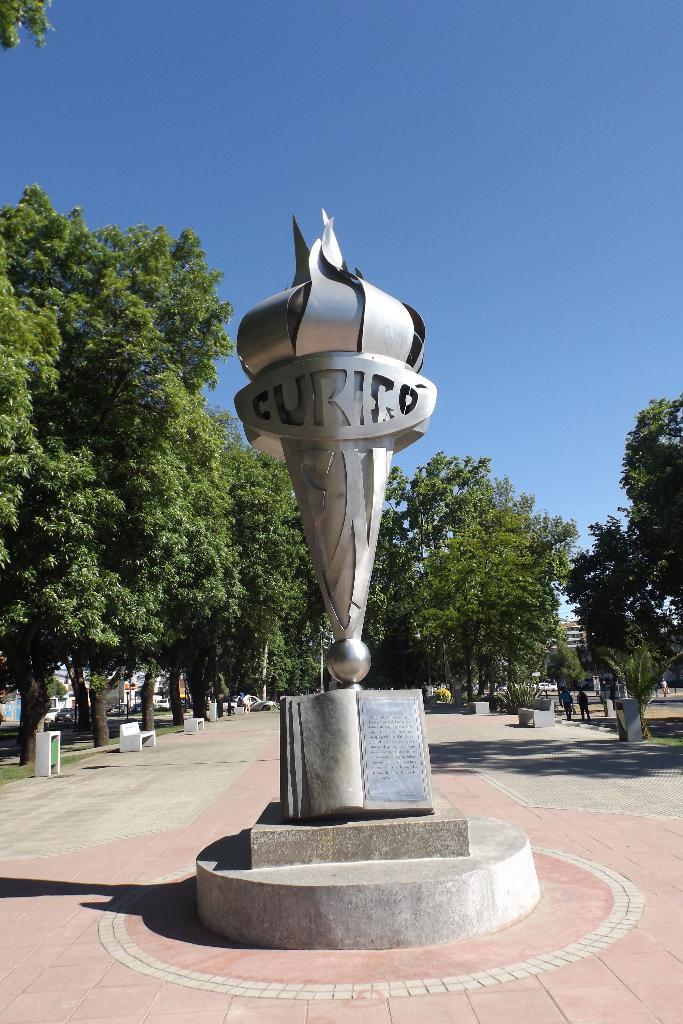What word is in the statue?
Your response must be concise. Curico. What is the symbol?
Ensure brevity in your answer.  Curico. 